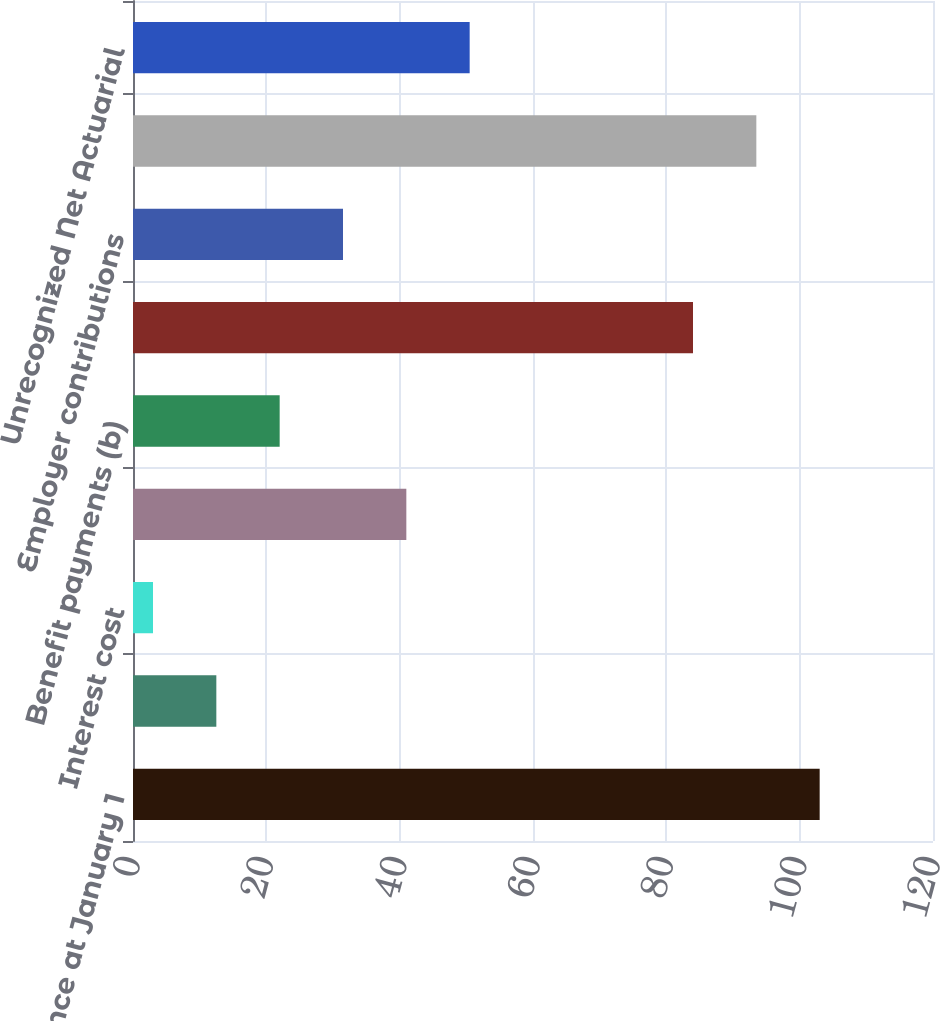<chart> <loc_0><loc_0><loc_500><loc_500><bar_chart><fcel>Balance at January 1<fcel>Service cost<fcel>Interest cost<fcel>Actuarial loss (gain) (a)<fcel>Benefit payments (b)<fcel>Balance at December 31<fcel>Employer contributions<fcel>Funded Status (Plan assets<fcel>Unrecognized Net Actuarial<nl><fcel>103<fcel>12.5<fcel>3<fcel>41<fcel>22<fcel>84<fcel>31.5<fcel>93.5<fcel>50.5<nl></chart> 